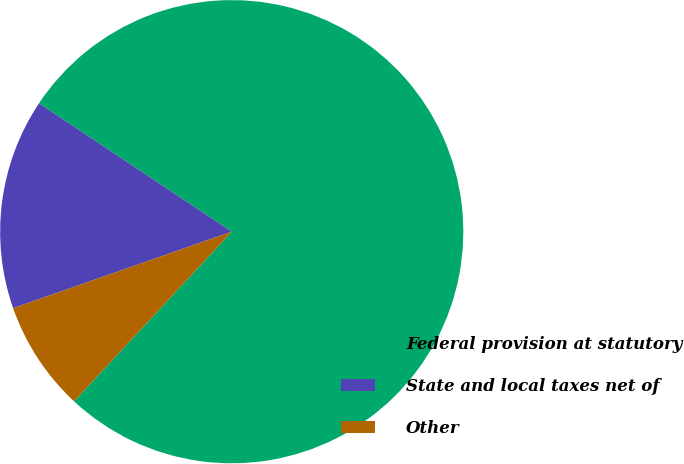Convert chart to OTSL. <chart><loc_0><loc_0><loc_500><loc_500><pie_chart><fcel>Federal provision at statutory<fcel>State and local taxes net of<fcel>Other<nl><fcel>77.57%<fcel>14.71%<fcel>7.72%<nl></chart> 